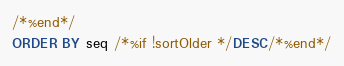Convert code to text. <code><loc_0><loc_0><loc_500><loc_500><_SQL_>/*%end*/
ORDER BY seq /*%if !sortOlder */DESC/*%end*/
</code> 